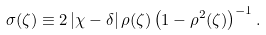Convert formula to latex. <formula><loc_0><loc_0><loc_500><loc_500>\sigma ( \zeta ) \equiv 2 \left | \chi - \delta \right | \rho ( \zeta ) \left ( 1 - \rho ^ { 2 } ( \zeta ) \right ) ^ { - 1 } . \,</formula> 